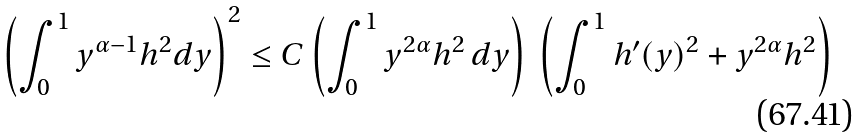Convert formula to latex. <formula><loc_0><loc_0><loc_500><loc_500>\left ( \int _ { 0 } ^ { 1 } y ^ { \alpha - 1 } h ^ { 2 } d y \right ) ^ { 2 } \leq C \left ( \int _ { 0 } ^ { 1 } y ^ { 2 \alpha } h ^ { 2 } \, d y \right ) \ \left ( \int _ { 0 } ^ { 1 } h ^ { \prime } ( y ) ^ { 2 } + y ^ { 2 \alpha } h ^ { 2 } \right )</formula> 